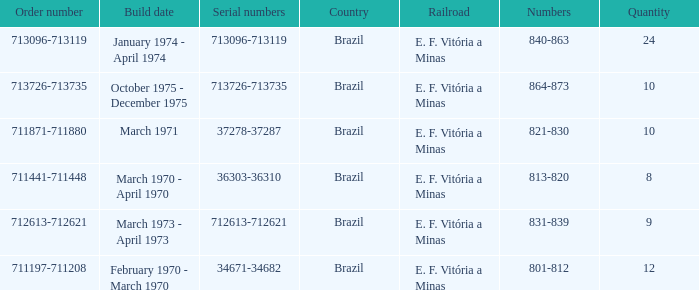Can you parse all the data within this table? {'header': ['Order number', 'Build date', 'Serial numbers', 'Country', 'Railroad', 'Numbers', 'Quantity'], 'rows': [['713096-713119', 'January 1974 - April 1974', '713096-713119', 'Brazil', 'E. F. Vitória a Minas', '840-863', '24'], ['713726-713735', 'October 1975 - December 1975', '713726-713735', 'Brazil', 'E. F. Vitória a Minas', '864-873', '10'], ['711871-711880', 'March 1971', '37278-37287', 'Brazil', 'E. F. Vitória a Minas', '821-830', '10'], ['711441-711448', 'March 1970 - April 1970', '36303-36310', 'Brazil', 'E. F. Vitória a Minas', '813-820', '8'], ['712613-712621', 'March 1973 - April 1973', '712613-712621', 'Brazil', 'E. F. Vitória a Minas', '831-839', '9'], ['711197-711208', 'February 1970 - March 1970', '34671-34682', 'Brazil', 'E. F. Vitória a Minas', '801-812', '12']]} What are the numbers for the order number 713096-713119? 840-863. 